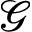Convert formula to latex. <formula><loc_0><loc_0><loc_500><loc_500>\mathcal { G }</formula> 